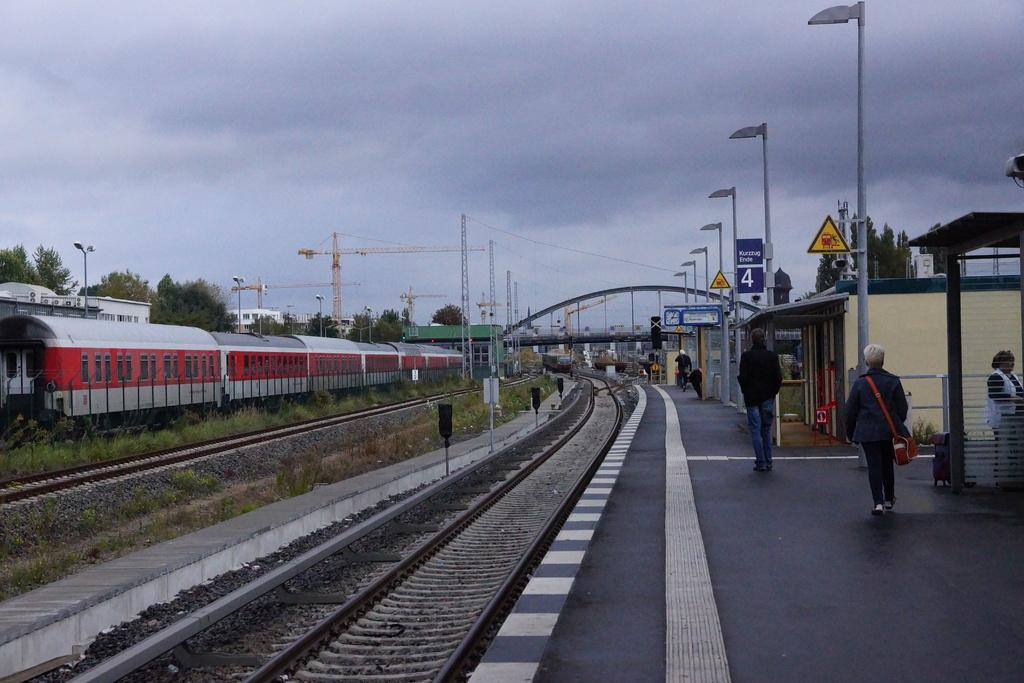What type of infrastructure is visible in the image? There are railway tracks in the image. What else can be seen alongside the railway tracks? There are poles, trees, and towers in the image. What are the people in the image doing? People are walking on a railway platform in the image. Are there any signs or notices in the image? Yes, sign boards are present in the image. What is visible in the background of the image? The sky is visible in the background of the image. Who is the owner of the suit seen in the image? There is no suit present in the image, so it is not possible to determine the owner. 